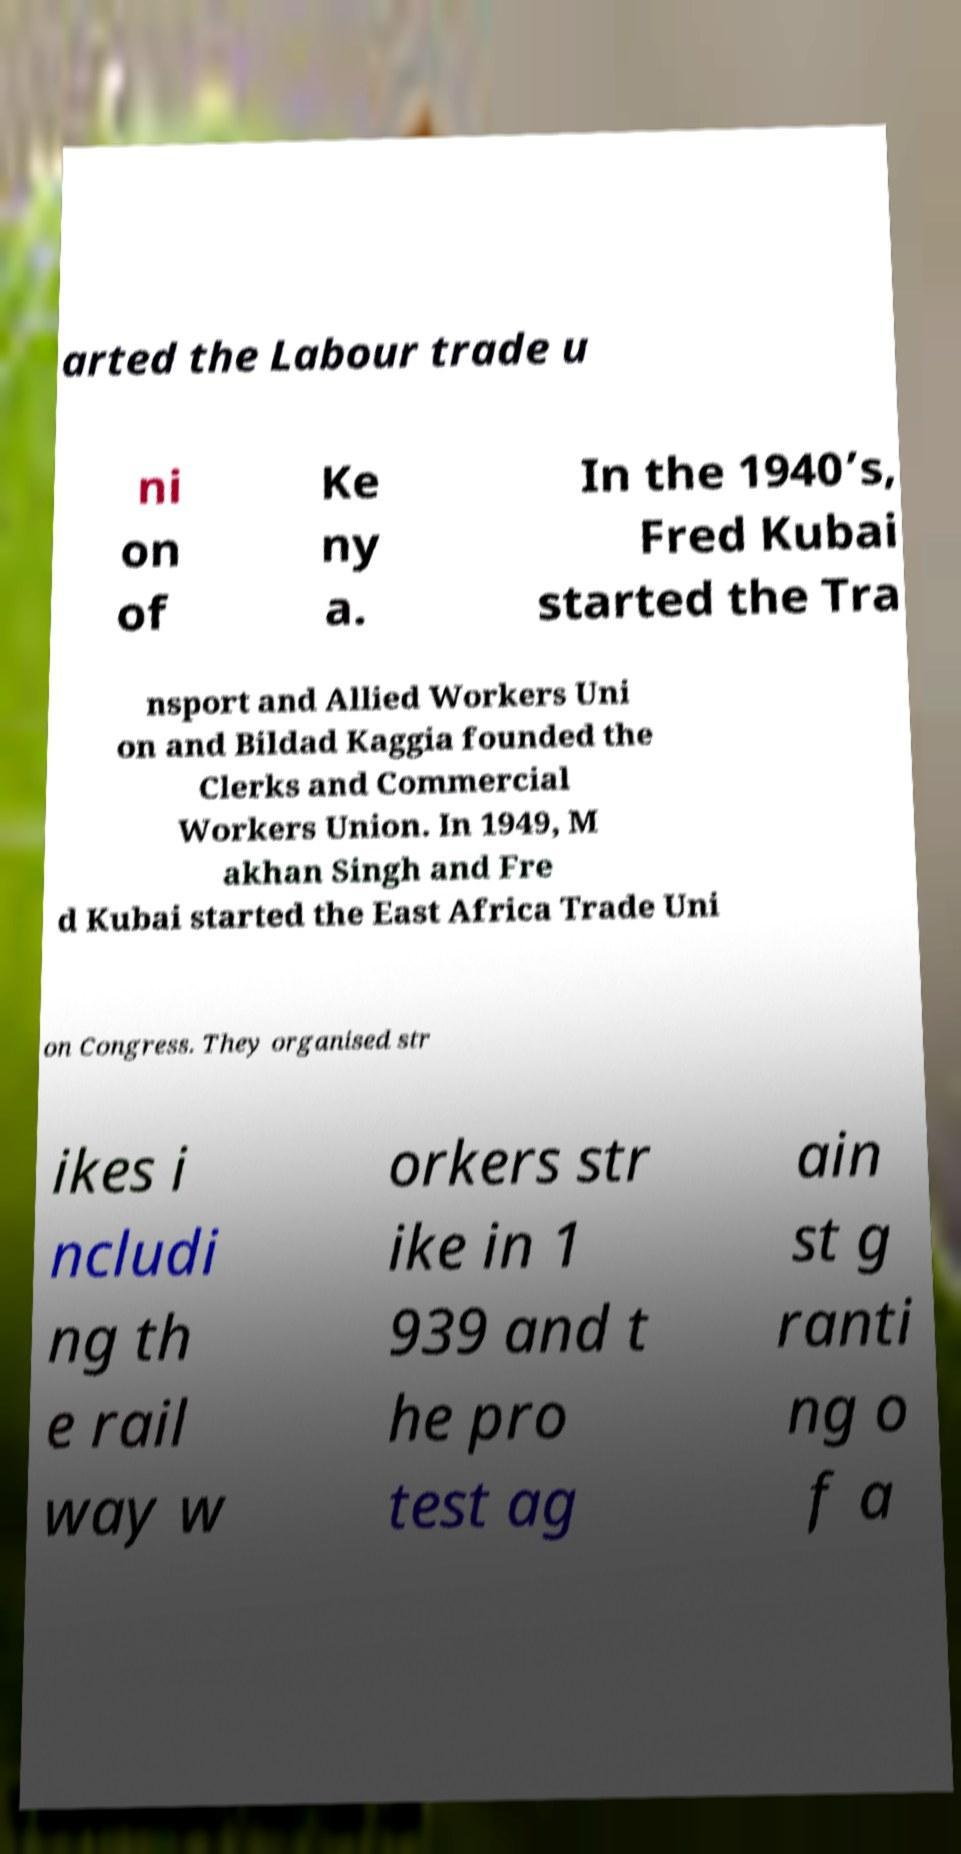There's text embedded in this image that I need extracted. Can you transcribe it verbatim? arted the Labour trade u ni on of Ke ny a. In the 1940’s, Fred Kubai started the Tra nsport and Allied Workers Uni on and Bildad Kaggia founded the Clerks and Commercial Workers Union. In 1949, M akhan Singh and Fre d Kubai started the East Africa Trade Uni on Congress. They organised str ikes i ncludi ng th e rail way w orkers str ike in 1 939 and t he pro test ag ain st g ranti ng o f a 